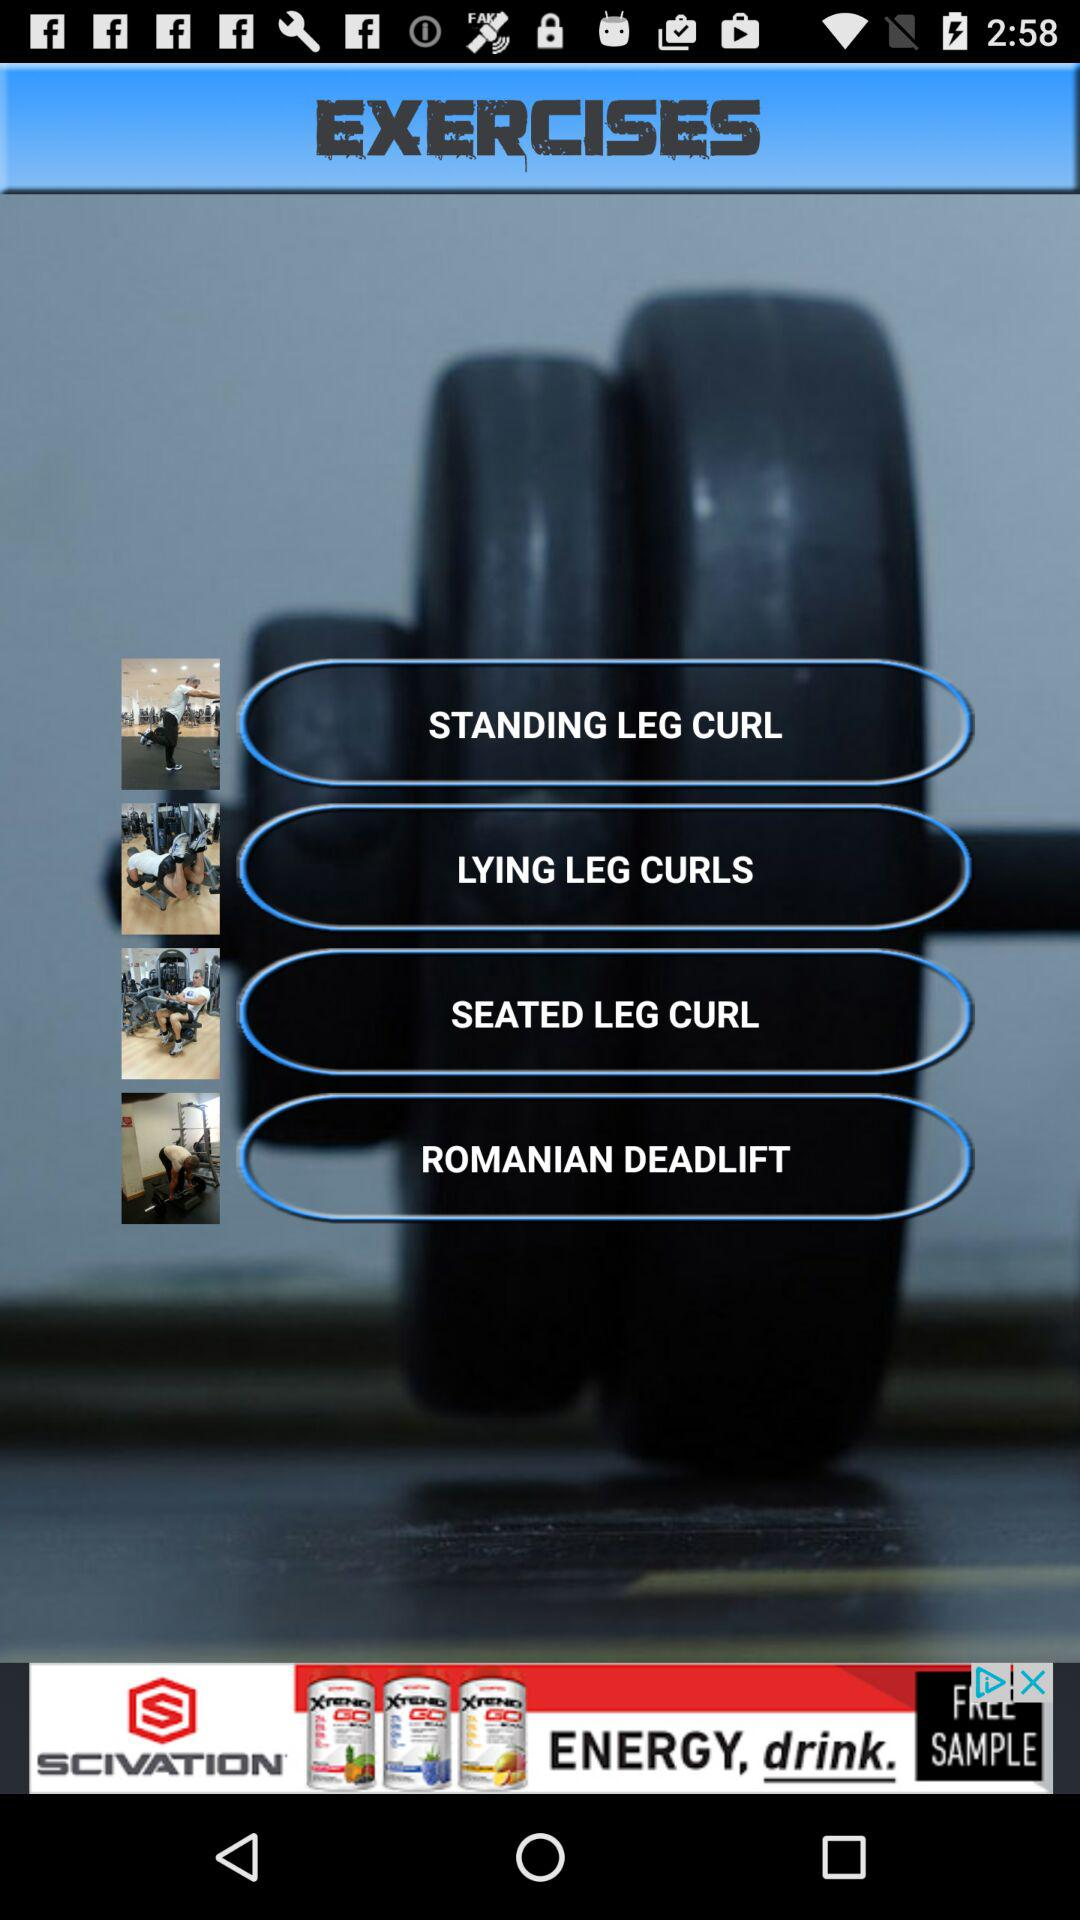Which exercises are there in the application? The exercises are standing leg curl, lying leg curls, seated leg curl and Romanian deadlift. 